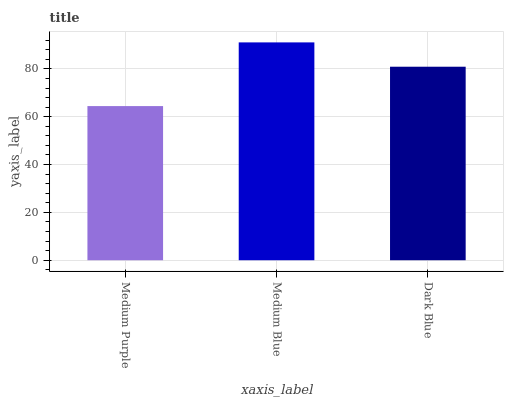Is Medium Purple the minimum?
Answer yes or no. Yes. Is Medium Blue the maximum?
Answer yes or no. Yes. Is Dark Blue the minimum?
Answer yes or no. No. Is Dark Blue the maximum?
Answer yes or no. No. Is Medium Blue greater than Dark Blue?
Answer yes or no. Yes. Is Dark Blue less than Medium Blue?
Answer yes or no. Yes. Is Dark Blue greater than Medium Blue?
Answer yes or no. No. Is Medium Blue less than Dark Blue?
Answer yes or no. No. Is Dark Blue the high median?
Answer yes or no. Yes. Is Dark Blue the low median?
Answer yes or no. Yes. Is Medium Blue the high median?
Answer yes or no. No. Is Medium Blue the low median?
Answer yes or no. No. 